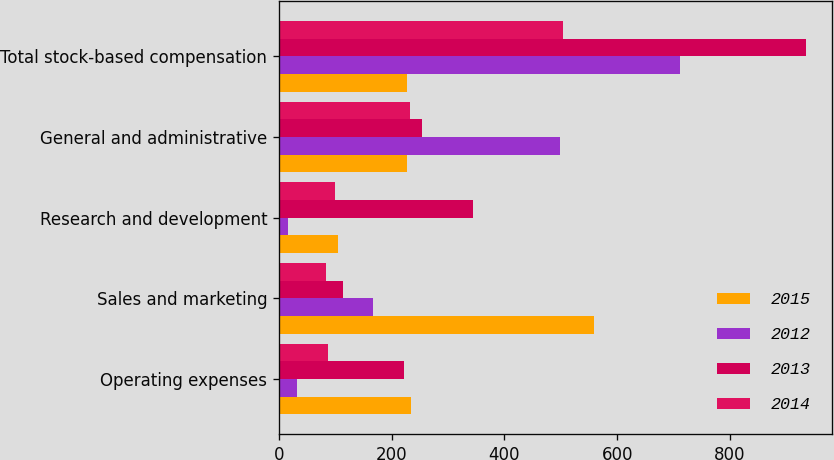Convert chart. <chart><loc_0><loc_0><loc_500><loc_500><stacked_bar_chart><ecel><fcel>Operating expenses<fcel>Sales and marketing<fcel>Research and development<fcel>General and administrative<fcel>Total stock-based compensation<nl><fcel>2015<fcel>235<fcel>559<fcel>104<fcel>227.5<fcel>227.5<nl><fcel>2012<fcel>32<fcel>166<fcel>16<fcel>498<fcel>712<nl><fcel>2013<fcel>222<fcel>114<fcel>345<fcel>253<fcel>934<nl><fcel>2014<fcel>87<fcel>83<fcel>100<fcel>233<fcel>503<nl></chart> 